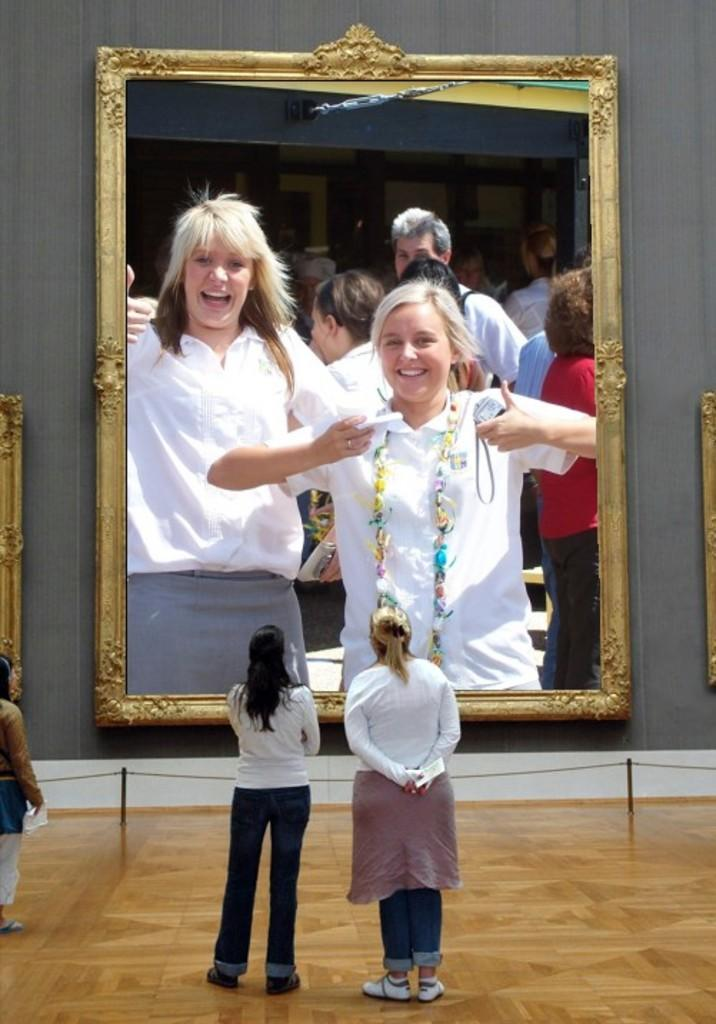How many people are in the foreground of the image? There are three persons standing in the foreground of the image. What are the people looking at in the image? The three persons are looking at a big photo frame. Where is the photo frame located in the image? The photo frame is attached to a wall. What type of chain is holding the photo frame to the wall? There is no chain visible in the image; the photo frame is attached to the wall without any visible chain. 